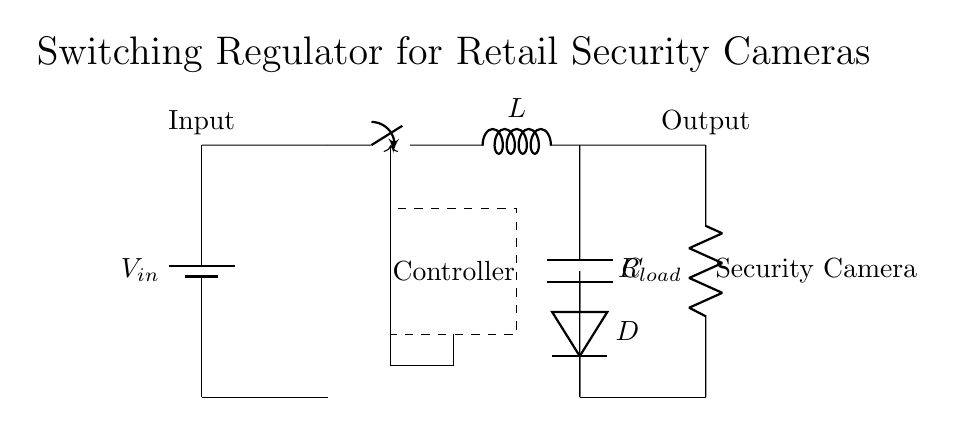What is the input voltage represented in the circuit? The input voltage is indicated by the label next to the battery component, which is denoted as V_in. This is typically the voltage source being used to power the circuit.
Answer: V_in What type of inductor is used in this circuit? The type of inductor is represented by the symbol L in the circuit diagram. It is a standard inductor used to store energy when current flows through it.
Answer: L How many main components are there in this switching regulator? The main components include the battery, switch, inductor, diode, capacitor, load resistor, and controller. Counting these gives a total of six essential components in this circuit.
Answer: Six What role does the diode play in this circuit? The diode (D) is used to allow current to flow in one direction, preventing reverse flow which could damage other components. This is important in a switching regulator to maintain proper voltage and current direction.
Answer: Prevents reverse flow What is the purpose of the capacitor in the circuit? The capacitor (C) is used to smooth out voltage fluctuations and provide a stable output voltage to the load. It stores charge and releases it to maintain a constant voltage level when the load draws current.
Answer: Smooths output voltage Why is a controller included in this circuit? The controller regulates the switching operation of the circuit by controlling the switch's timing. It modulates the duty cycle of the switch to maintain a specific output voltage level despite variations in input voltage or output load.
Answer: Regulates switching operation What type of load does this circuit power? The load, shown as R_load in the diagram, typically refers to a security camera in this context. It indicates that the circuit is designed to supply power to devices that require a certain voltage and current.
Answer: Security camera 